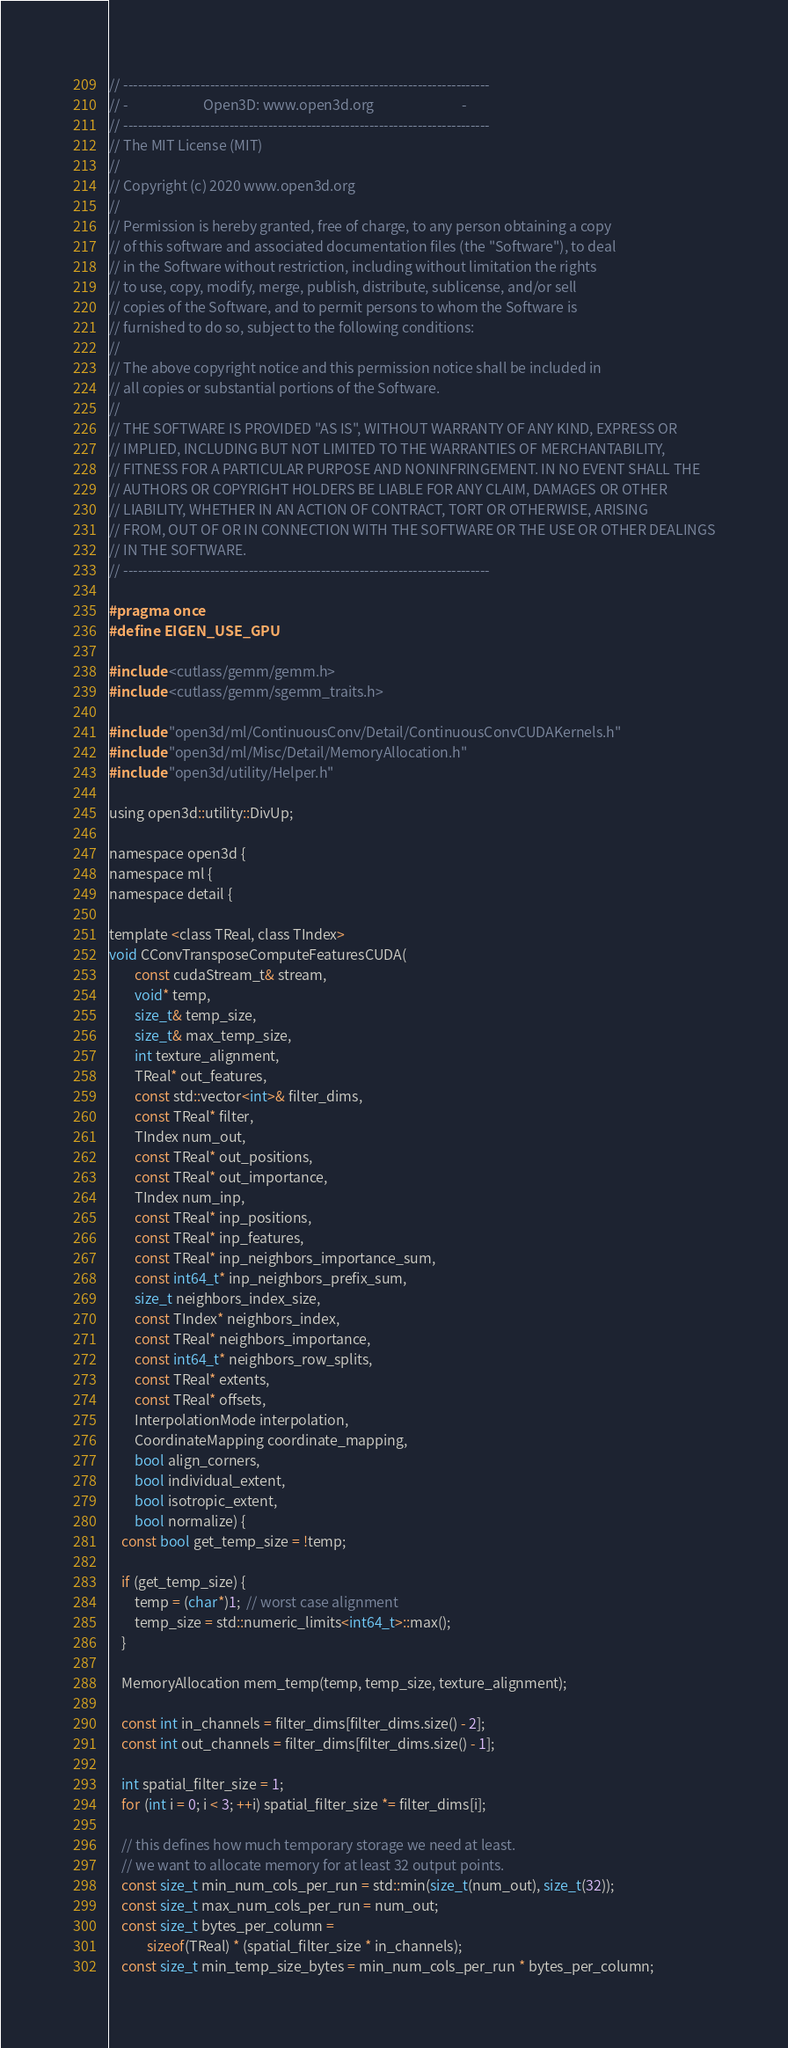<code> <loc_0><loc_0><loc_500><loc_500><_Cuda_>// ----------------------------------------------------------------------------
// -                        Open3D: www.open3d.org                            -
// ----------------------------------------------------------------------------
// The MIT License (MIT)
//
// Copyright (c) 2020 www.open3d.org
//
// Permission is hereby granted, free of charge, to any person obtaining a copy
// of this software and associated documentation files (the "Software"), to deal
// in the Software without restriction, including without limitation the rights
// to use, copy, modify, merge, publish, distribute, sublicense, and/or sell
// copies of the Software, and to permit persons to whom the Software is
// furnished to do so, subject to the following conditions:
//
// The above copyright notice and this permission notice shall be included in
// all copies or substantial portions of the Software.
//
// THE SOFTWARE IS PROVIDED "AS IS", WITHOUT WARRANTY OF ANY KIND, EXPRESS OR
// IMPLIED, INCLUDING BUT NOT LIMITED TO THE WARRANTIES OF MERCHANTABILITY,
// FITNESS FOR A PARTICULAR PURPOSE AND NONINFRINGEMENT. IN NO EVENT SHALL THE
// AUTHORS OR COPYRIGHT HOLDERS BE LIABLE FOR ANY CLAIM, DAMAGES OR OTHER
// LIABILITY, WHETHER IN AN ACTION OF CONTRACT, TORT OR OTHERWISE, ARISING
// FROM, OUT OF OR IN CONNECTION WITH THE SOFTWARE OR THE USE OR OTHER DEALINGS
// IN THE SOFTWARE.
// ----------------------------------------------------------------------------

#pragma once
#define EIGEN_USE_GPU

#include <cutlass/gemm/gemm.h>
#include <cutlass/gemm/sgemm_traits.h>

#include "open3d/ml/ContinuousConv/Detail/ContinuousConvCUDAKernels.h"
#include "open3d/ml/Misc/Detail/MemoryAllocation.h"
#include "open3d/utility/Helper.h"

using open3d::utility::DivUp;

namespace open3d {
namespace ml {
namespace detail {

template <class TReal, class TIndex>
void CConvTransposeComputeFeaturesCUDA(
        const cudaStream_t& stream,
        void* temp,
        size_t& temp_size,
        size_t& max_temp_size,
        int texture_alignment,
        TReal* out_features,
        const std::vector<int>& filter_dims,
        const TReal* filter,
        TIndex num_out,
        const TReal* out_positions,
        const TReal* out_importance,
        TIndex num_inp,
        const TReal* inp_positions,
        const TReal* inp_features,
        const TReal* inp_neighbors_importance_sum,
        const int64_t* inp_neighbors_prefix_sum,
        size_t neighbors_index_size,
        const TIndex* neighbors_index,
        const TReal* neighbors_importance,
        const int64_t* neighbors_row_splits,
        const TReal* extents,
        const TReal* offsets,
        InterpolationMode interpolation,
        CoordinateMapping coordinate_mapping,
        bool align_corners,
        bool individual_extent,
        bool isotropic_extent,
        bool normalize) {
    const bool get_temp_size = !temp;

    if (get_temp_size) {
        temp = (char*)1;  // worst case alignment
        temp_size = std::numeric_limits<int64_t>::max();
    }

    MemoryAllocation mem_temp(temp, temp_size, texture_alignment);

    const int in_channels = filter_dims[filter_dims.size() - 2];
    const int out_channels = filter_dims[filter_dims.size() - 1];

    int spatial_filter_size = 1;
    for (int i = 0; i < 3; ++i) spatial_filter_size *= filter_dims[i];

    // this defines how much temporary storage we need at least.
    // we want to allocate memory for at least 32 output points.
    const size_t min_num_cols_per_run = std::min(size_t(num_out), size_t(32));
    const size_t max_num_cols_per_run = num_out;
    const size_t bytes_per_column =
            sizeof(TReal) * (spatial_filter_size * in_channels);
    const size_t min_temp_size_bytes = min_num_cols_per_run * bytes_per_column;</code> 